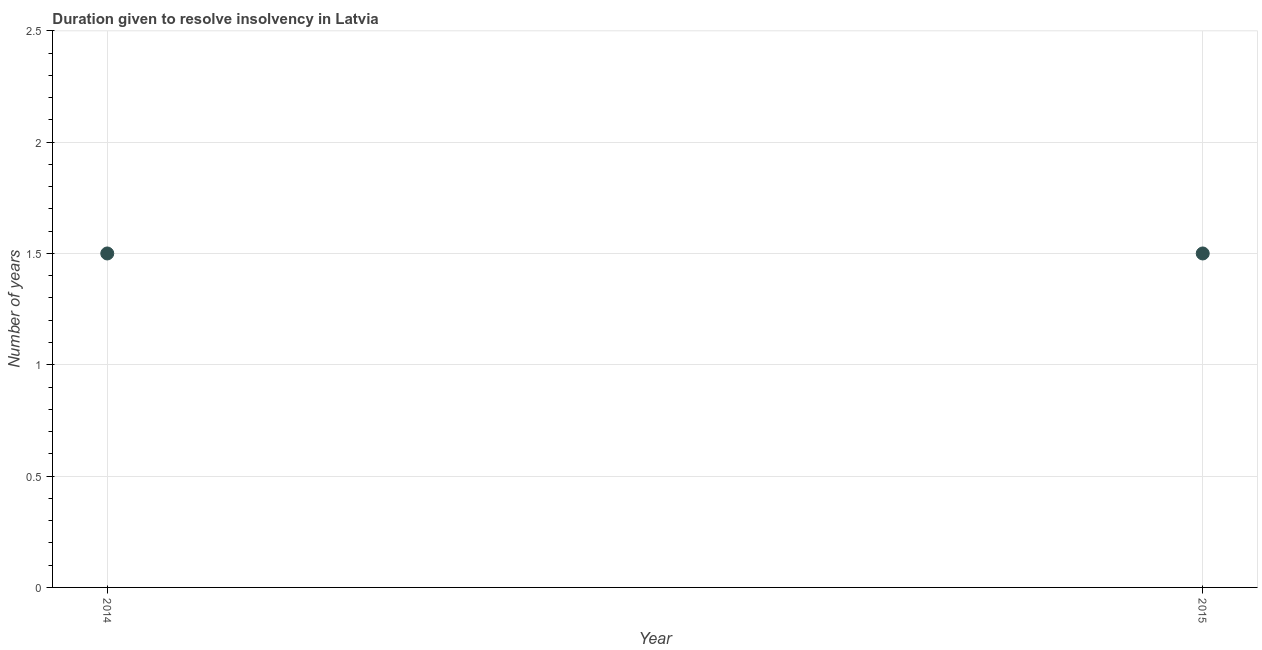What is the number of years to resolve insolvency in 2014?
Provide a succinct answer. 1.5. Across all years, what is the maximum number of years to resolve insolvency?
Keep it short and to the point. 1.5. Across all years, what is the minimum number of years to resolve insolvency?
Make the answer very short. 1.5. In which year was the number of years to resolve insolvency maximum?
Provide a succinct answer. 2014. What is the sum of the number of years to resolve insolvency?
Give a very brief answer. 3. What is the difference between the number of years to resolve insolvency in 2014 and 2015?
Your response must be concise. 0. What is the median number of years to resolve insolvency?
Ensure brevity in your answer.  1.5. What is the ratio of the number of years to resolve insolvency in 2014 to that in 2015?
Provide a succinct answer. 1. Is the number of years to resolve insolvency in 2014 less than that in 2015?
Your answer should be compact. No. How many years are there in the graph?
Offer a very short reply. 2. Are the values on the major ticks of Y-axis written in scientific E-notation?
Give a very brief answer. No. Does the graph contain any zero values?
Offer a terse response. No. Does the graph contain grids?
Offer a terse response. Yes. What is the title of the graph?
Offer a terse response. Duration given to resolve insolvency in Latvia. What is the label or title of the X-axis?
Offer a terse response. Year. What is the label or title of the Y-axis?
Provide a short and direct response. Number of years. What is the Number of years in 2014?
Make the answer very short. 1.5. 